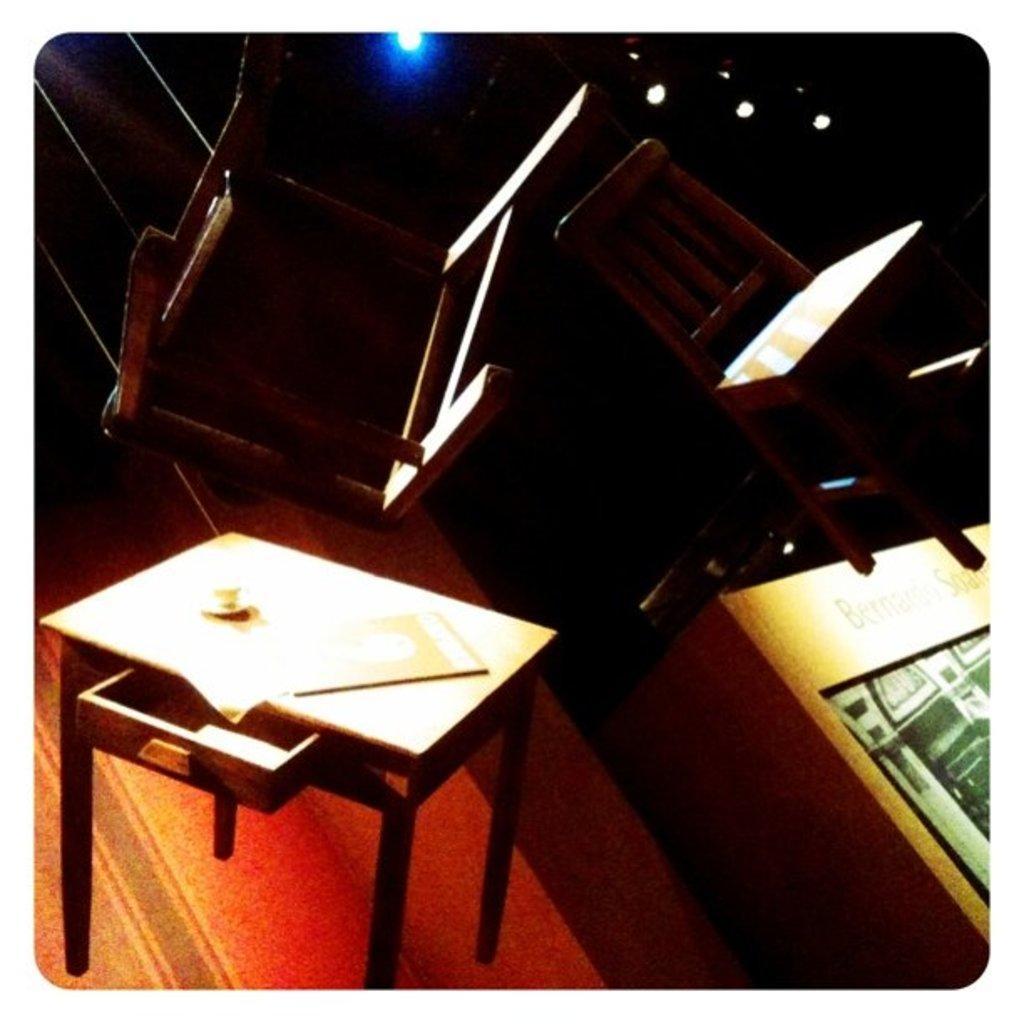Could you give a brief overview of what you see in this image? Background portion of the picture is dark. In this picture we can see the lights, chairs, table and few objects. 